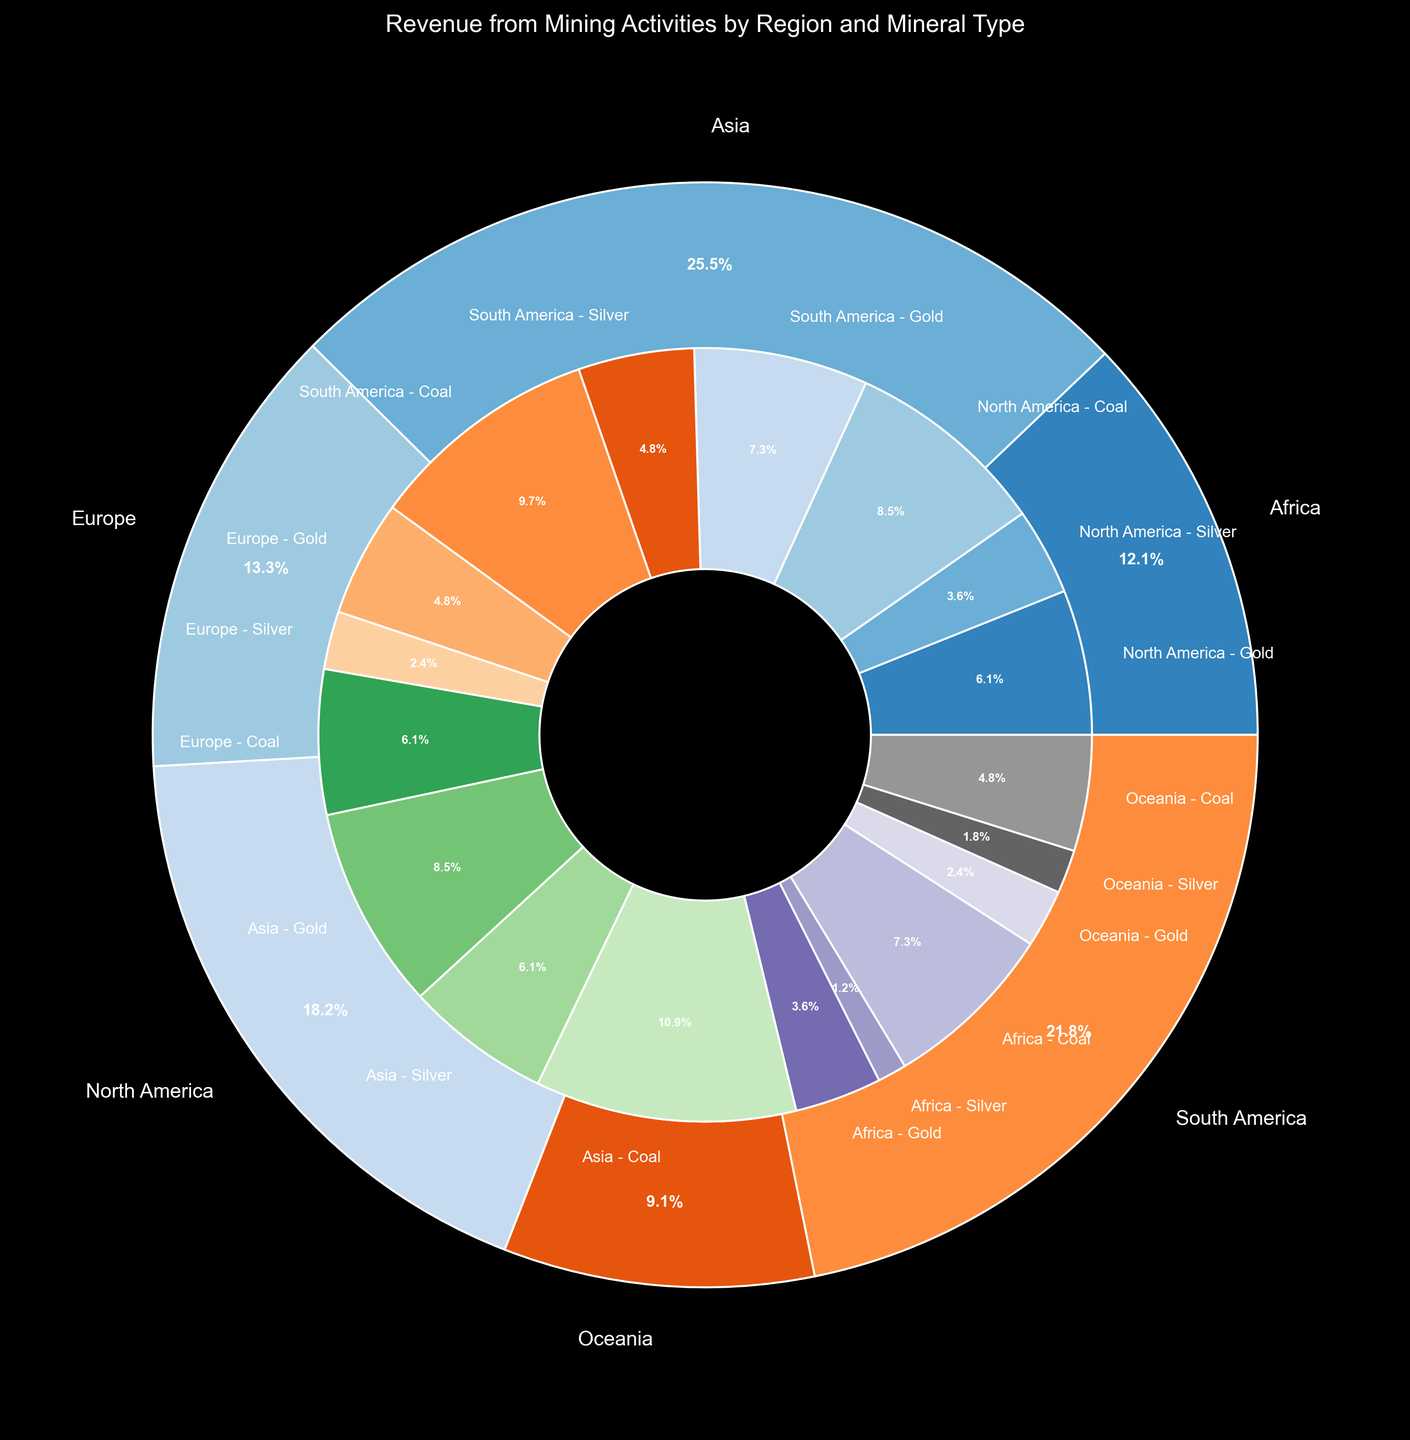What region has generated the highest total revenue from mining activities? The outer pie chart represents total revenue by region. The largest wedge represents Asia.
Answer: Asia Which mineral type has the highest revenue share in North America? Look at the inner pie chart section for North America, which consists of three minerals: Gold, Silver, and Coal. The section indicating Coal has the largest share.
Answer: Coal What is the combined revenue from Silver across all regions? Identify the Silver portion in each region’s inner pie chart segment and sum the respective revenues: $300M (NA) + $400M (SA) + $200M (EU) + $500M (AS) + $100M (AF) + $150M (OC) = $1650M.
Answer: $1650M Which region has the smallest contribution from Gold in terms of percentage? Look at each region's inner pie chart sections for the smallest Gold segment. Oceania has the smallest Gold segment.
Answer: Oceania How does the revenue from Coal in Europe compare to the revenue from Coal in Oceania? Compare the inner pie chart sections for Coal between Europe and Oceania. Europe and Oceania's sections show $500M and $400M, respectively. Europe has a higher revenue from Coal.
Answer: Europe What is the average revenue from mining activities in South America? The total revenue for South America is given by summing its Gold, Silver, and Coal revenues: $600M + $400M + $800M = $1800M. Divide this by the number of minerals (3) to find the average: $1800M / 3 = $600M.
Answer: $600M Which region has the closest revenue from Gold to North America's Gold revenue? North America’s revenue from Gold is $500M. The closest to this among other regions is Europe with $400M.
Answer: Europe Calculate the difference in total revenue from mining activities between Asia and Africa. Summing the revenues for Asia and Africa: ($700M + $500M + $900M) = $2100M for Asia and ($300M + $100M + $600M) = $1000M for Africa. The difference is $2100M - $1000M = $1100M.
Answer: $1100M Which mineral type has the highest revenue contribution across all regions combined? Summing the revenues for each mineral type across all regions: Gold: $2.7B, Silver: $1.65B, Coal: $3.9B. Coal has the highest combined revenue.
Answer: Coal 